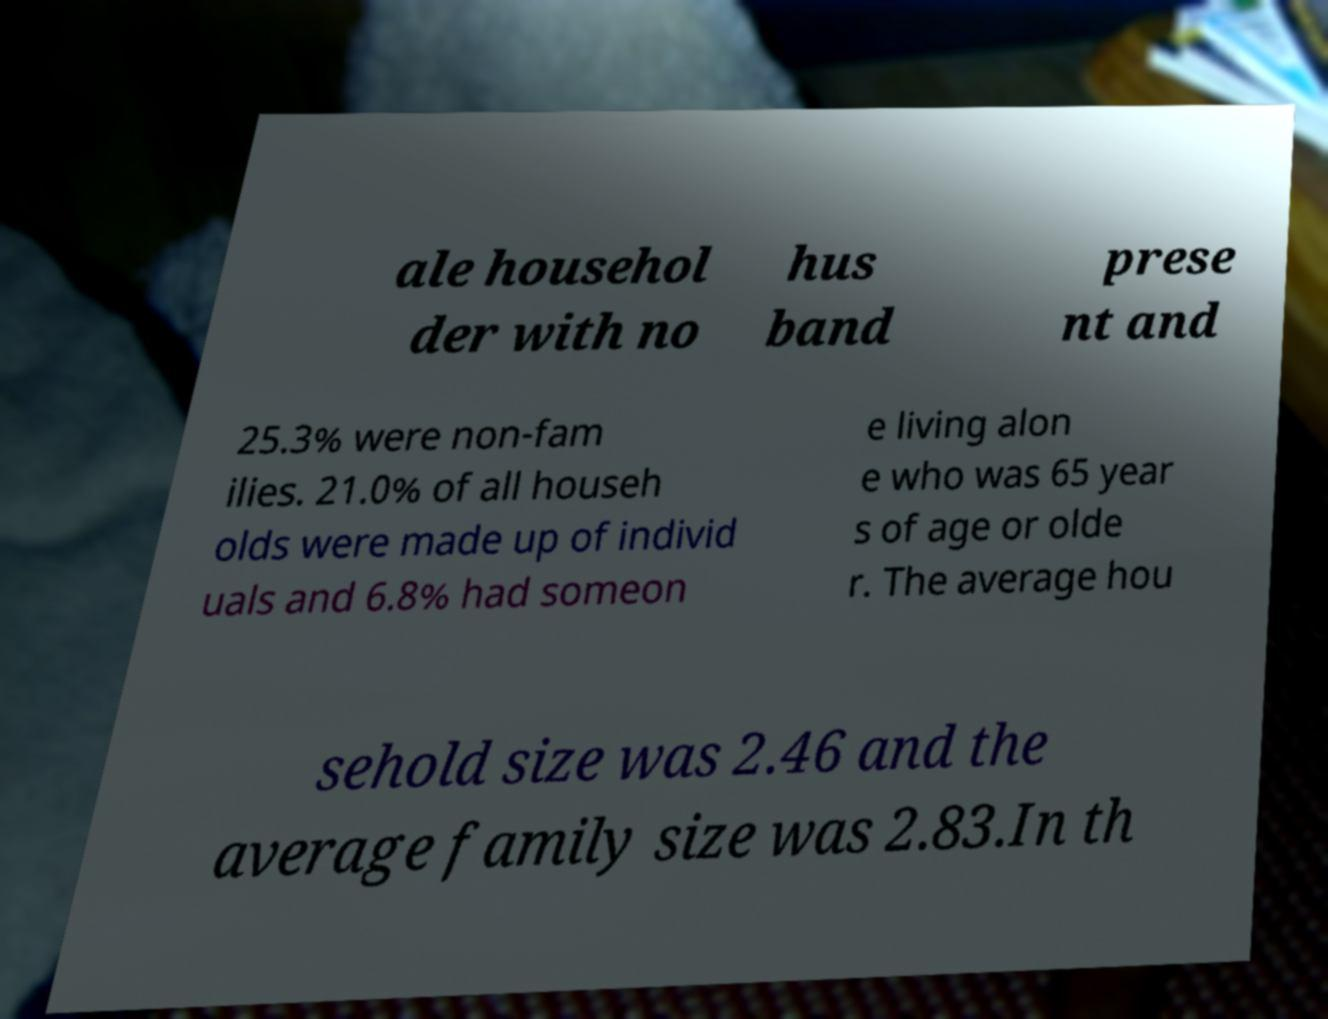Can you accurately transcribe the text from the provided image for me? ale househol der with no hus band prese nt and 25.3% were non-fam ilies. 21.0% of all househ olds were made up of individ uals and 6.8% had someon e living alon e who was 65 year s of age or olde r. The average hou sehold size was 2.46 and the average family size was 2.83.In th 